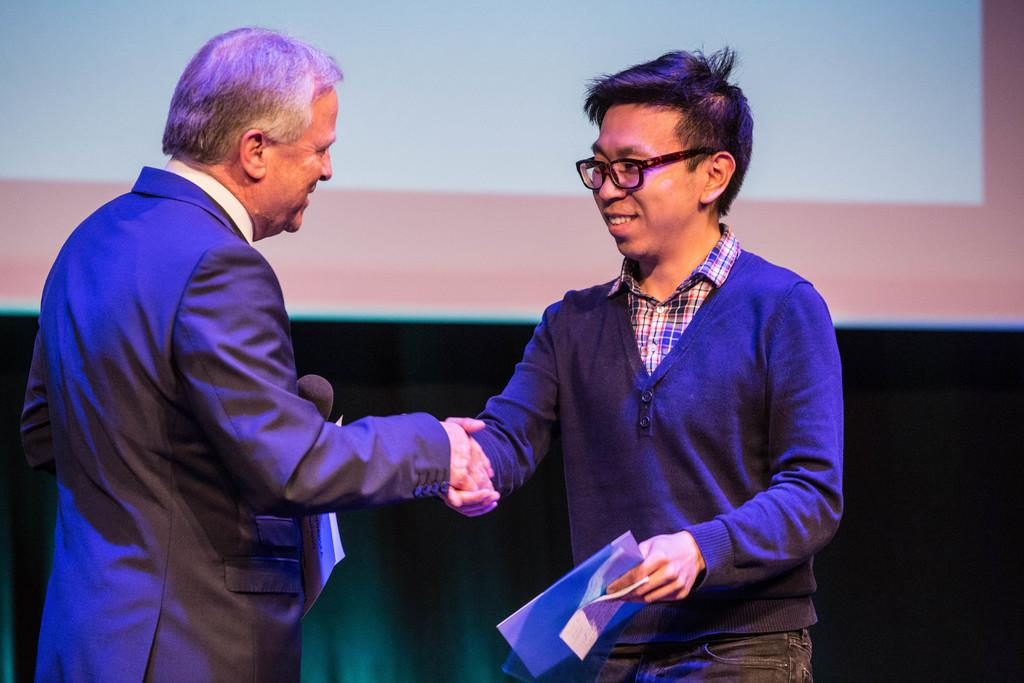How many people are in the image? There are two men in the image. What are the men doing in the center of the image? The men are shaking hands in the center of the image. What objects are the men holding in their hands? The men are holding papers in their hands. What level of government is represented by the men in the image? There is no indication of the level of government represented by the men in the image. The image only shows two men shaking hands and holding papers. 